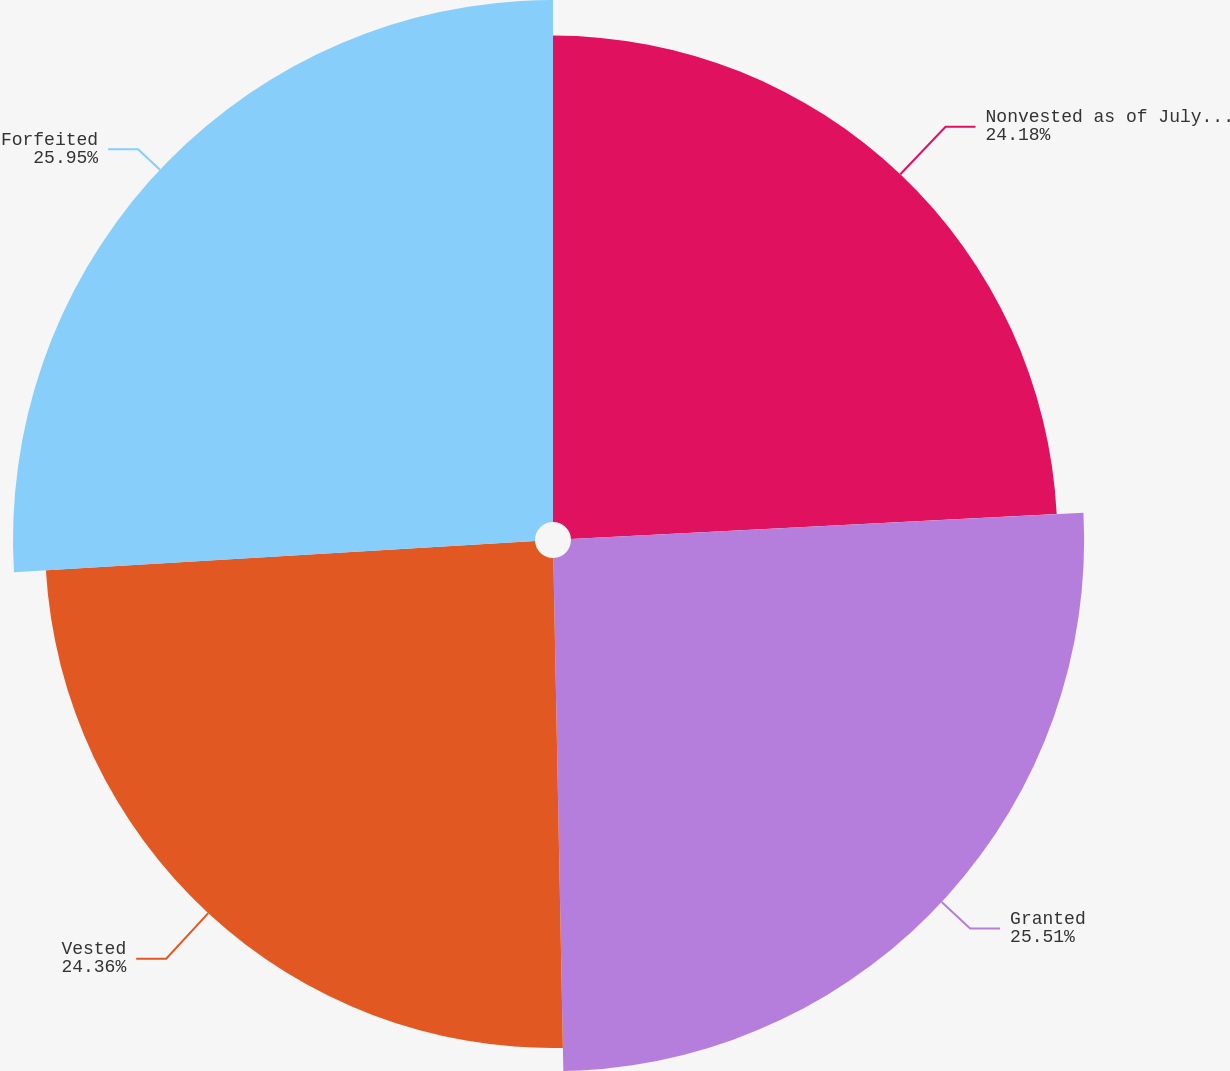Convert chart. <chart><loc_0><loc_0><loc_500><loc_500><pie_chart><fcel>Nonvested as of July 3 2010<fcel>Granted<fcel>Vested<fcel>Forfeited<nl><fcel>24.18%<fcel>25.51%<fcel>24.36%<fcel>25.95%<nl></chart> 